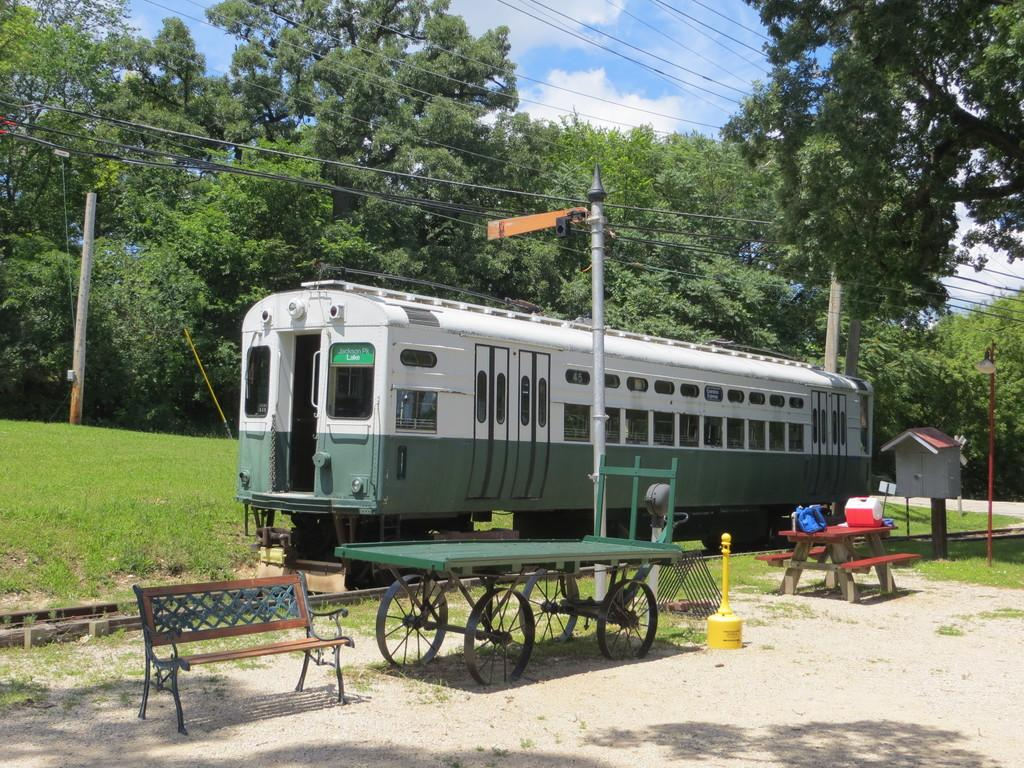What is the main subject of the image? The main subject of the image is a train. What can be seen in the image besides the train? There is a track, a bench, another table and bench, a pole, grass, trees, some wires, and the sky visible in the image. Can you describe the setting of the image? The image appears to be set in an outdoor area with grass, trees, and a sky visible in the background. What type of structure is present in the image? There is a bench and another table and bench present in the image. What else can be seen in the sky? The sky is visible in the image, but there is no additional information provided about its appearance. How many minutes does it take for the train to reach the edge of the image? The image is a still photograph and does not depict motion or time, so it is not possible to determine how many minutes it would take for the train to reach the edge of the image. 